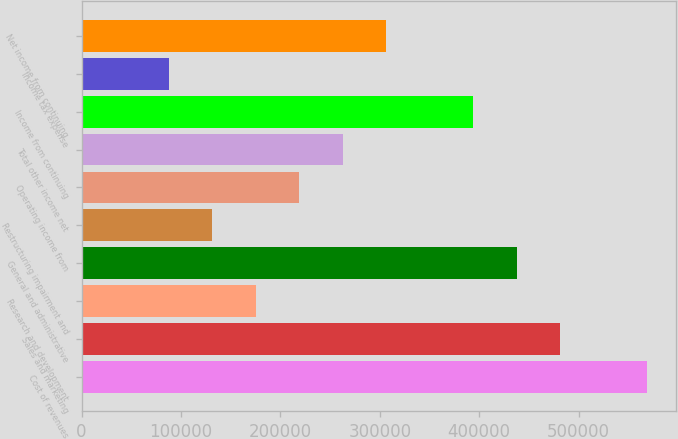Convert chart. <chart><loc_0><loc_0><loc_500><loc_500><bar_chart><fcel>Cost of revenues<fcel>Sales and marketing<fcel>Research and development<fcel>General and administrative<fcel>Restructuring impairment and<fcel>Operating income from<fcel>Total other income net<fcel>Income from continuing<fcel>Income tax expense<fcel>Net income from continuing<nl><fcel>569234<fcel>481659<fcel>175149<fcel>437872<fcel>131362<fcel>218936<fcel>262723<fcel>394085<fcel>87574.4<fcel>306510<nl></chart> 